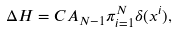<formula> <loc_0><loc_0><loc_500><loc_500>\Delta H = C A _ { N - 1 } \pi _ { i = 1 } ^ { N } \delta ( x ^ { i } ) ,</formula> 